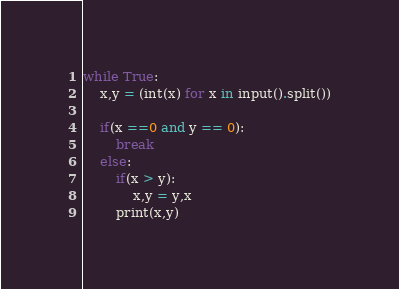Convert code to text. <code><loc_0><loc_0><loc_500><loc_500><_Python_>while True:
    x,y = (int(x) for x in input().split())
    
    if(x ==0 and y == 0):
        break
    else:
        if(x > y):
            x,y = y,x
        print(x,y)


</code> 